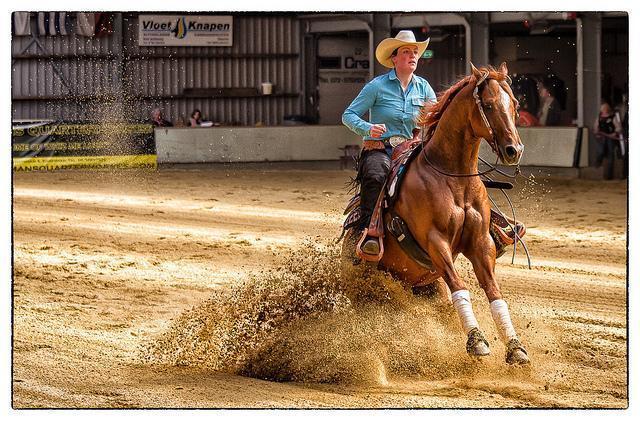How many people are there?
Give a very brief answer. 1. How many giraffe do you see?
Give a very brief answer. 0. 